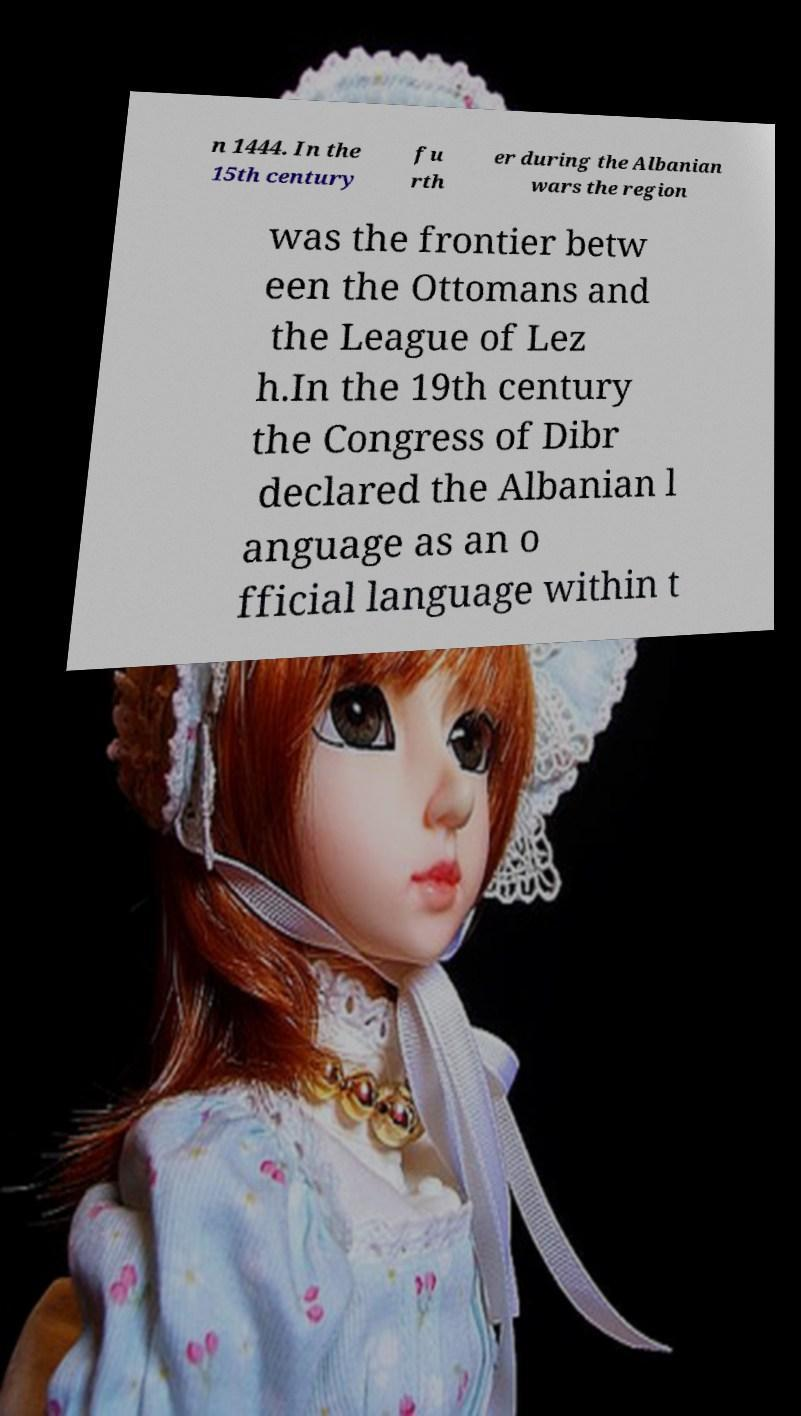Please identify and transcribe the text found in this image. n 1444. In the 15th century fu rth er during the Albanian wars the region was the frontier betw een the Ottomans and the League of Lez h.In the 19th century the Congress of Dibr declared the Albanian l anguage as an o fficial language within t 